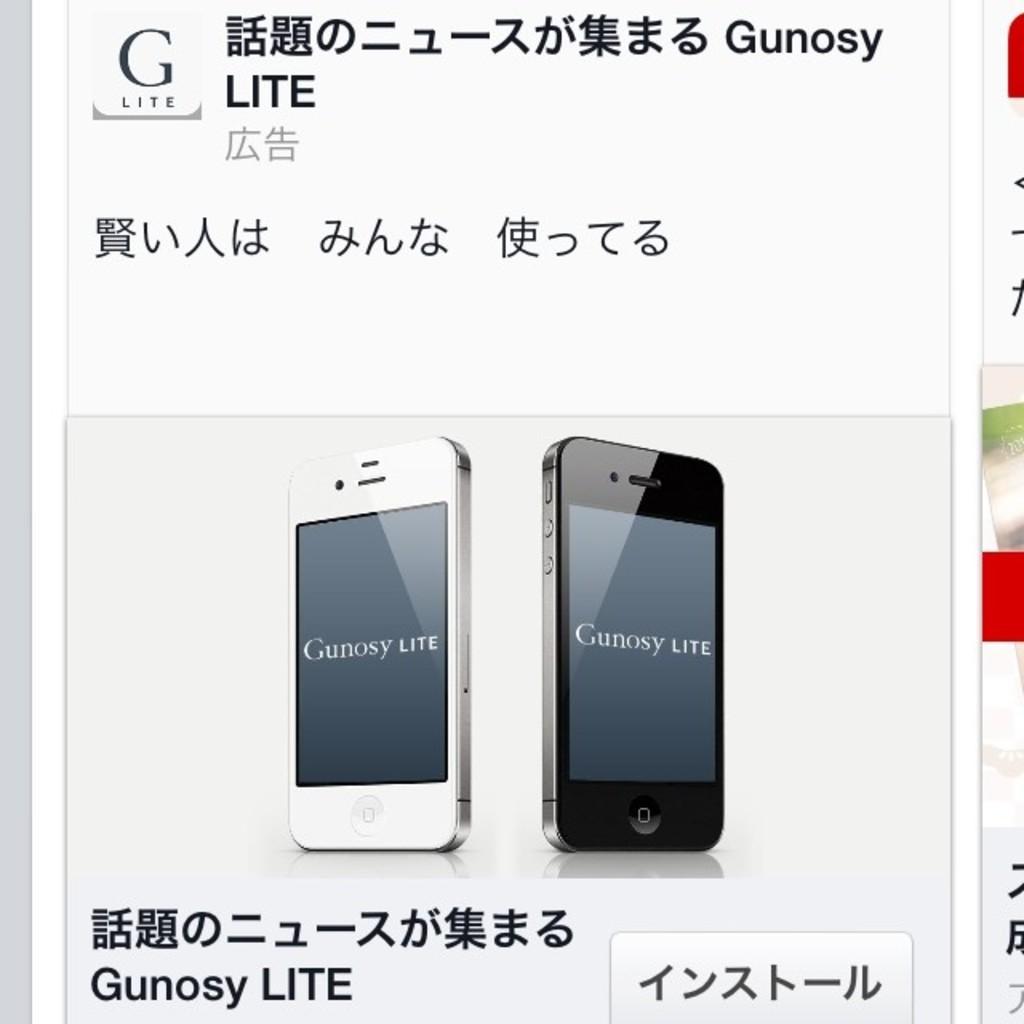What brand of phone is this?
Give a very brief answer. Gunosy lite. 